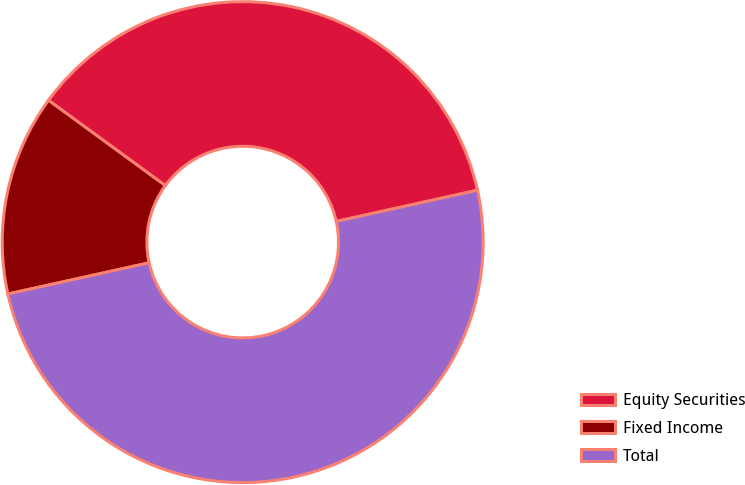Convert chart. <chart><loc_0><loc_0><loc_500><loc_500><pie_chart><fcel>Equity Securities<fcel>Fixed Income<fcel>Total<nl><fcel>36.5%<fcel>13.5%<fcel>50.0%<nl></chart> 